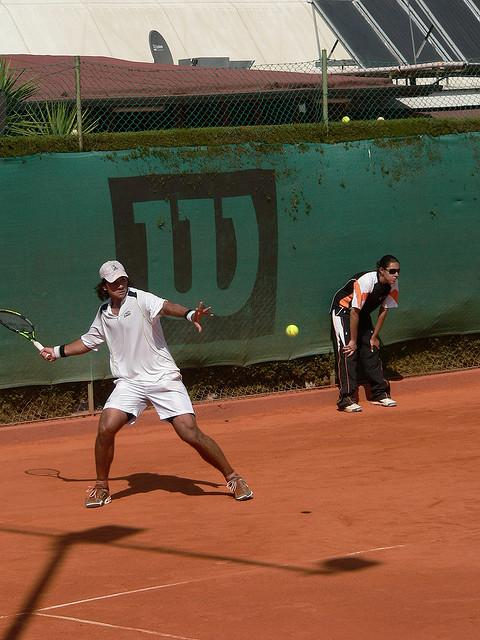What company is sponsoring the tennis match?

Choices:
A) dunlop
B) asics
C) gamma
D) wilson wilson 